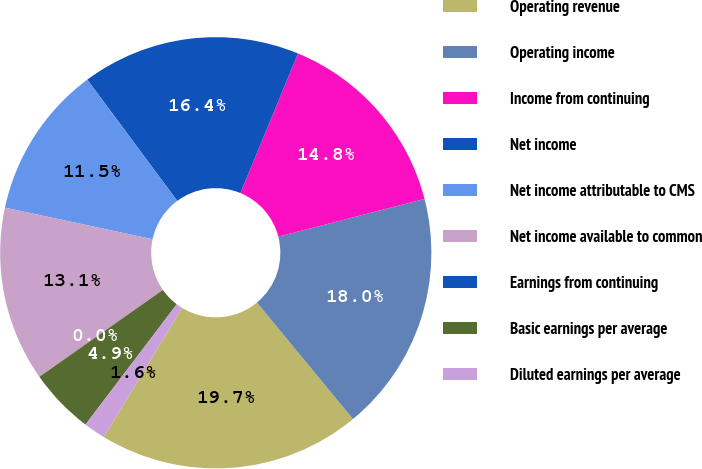Convert chart. <chart><loc_0><loc_0><loc_500><loc_500><pie_chart><fcel>Operating revenue<fcel>Operating income<fcel>Income from continuing<fcel>Net income<fcel>Net income attributable to CMS<fcel>Net income available to common<fcel>Earnings from continuing<fcel>Basic earnings per average<fcel>Diluted earnings per average<nl><fcel>19.67%<fcel>18.03%<fcel>14.75%<fcel>16.39%<fcel>11.48%<fcel>13.11%<fcel>0.0%<fcel>4.92%<fcel>1.64%<nl></chart> 